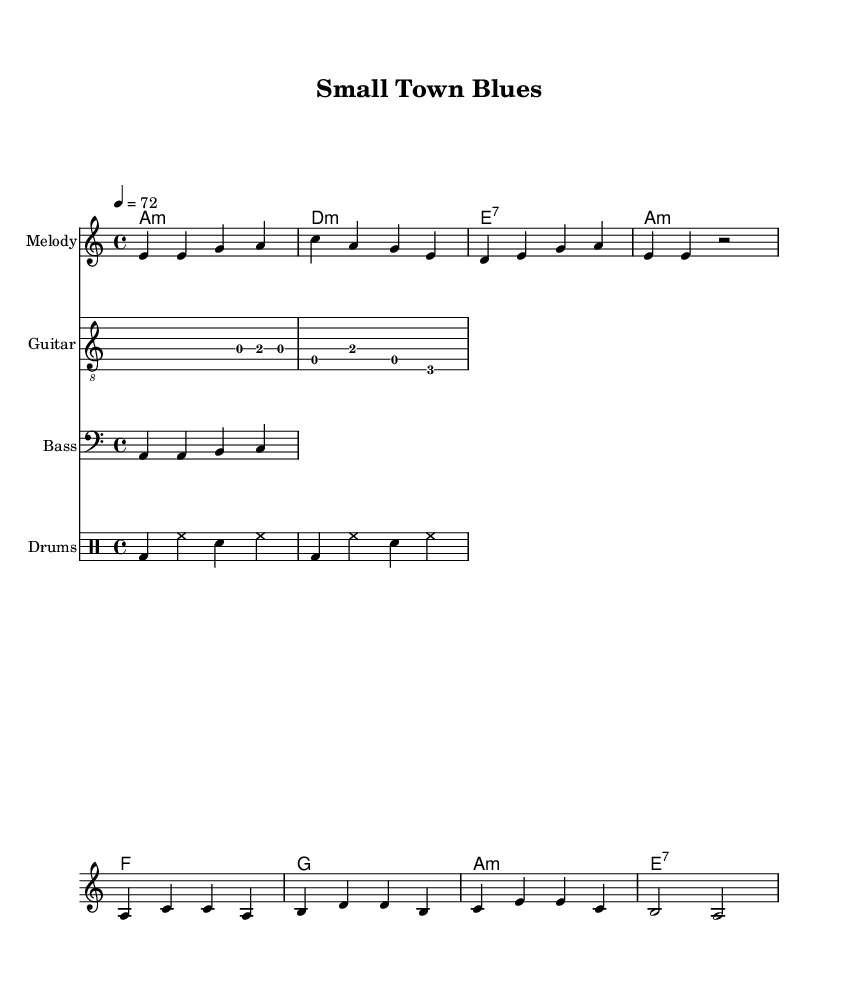What is the time signature of this music? The time signature is indicated at the beginning of the score as 4/4, which means there are four beats in each measure and the quarter note receives one beat.
Answer: 4/4 What is the key signature of this piece? The key signature shown in the music indicates A minor, which has no sharps or flats. This is determined by the absence of any sharps or flats in the key signature section at the start of the score.
Answer: A minor What is the tempo marking for this composition? The tempo marking is found in the score as "4 = 72," which means the piece should be played at a tempo where there are 72 quarter note beats in one minute.
Answer: 72 Which musical mode is primarily utilized in the harmonies? The harmonies section showcases various chords, where the presence of minor chords (A minor, D minor) and dominant seventh chords (E7) indicates a minor mode predominantly used throughout the piece.
Answer: Minor How many measures are in the verse section? The verse section consists of 4 measures as represented by the 4 lines in the melodyVerse part of the score. Each measure is distinctly separated by vertical lines.
Answer: 4 What distinct rhythmic instrument pattern is used in the drums? The rhythmic pattern used in the drum section is characterized by bass drum and snare hits along with hi-hat, alternating between strong beats (bass and snare) and weaker subdivisions (hi-hat), typical for a blues ensemble.
Answer: Bass and snare What is the lyrical theme reflected in the chorus? The lyrical theme expressed in the chorus revolves around community and connection, emphasizing unity in life and death, which resonates with the heartfelt nature of Electric Blues.
Answer: Community and connection 